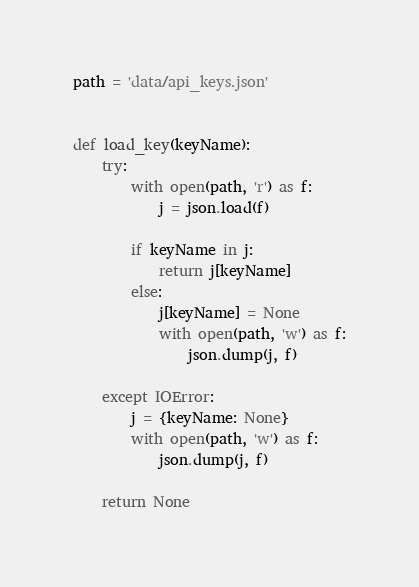Convert code to text. <code><loc_0><loc_0><loc_500><loc_500><_Python_>
path = 'data/api_keys.json'


def load_key(keyName):
    try:
        with open(path, 'r') as f:
            j = json.load(f)

        if keyName in j:
            return j[keyName]
        else:
            j[keyName] = None
            with open(path, 'w') as f:
                json.dump(j, f)

    except IOError:
        j = {keyName: None}
        with open(path, 'w') as f:
            json.dump(j, f)

    return None
</code> 